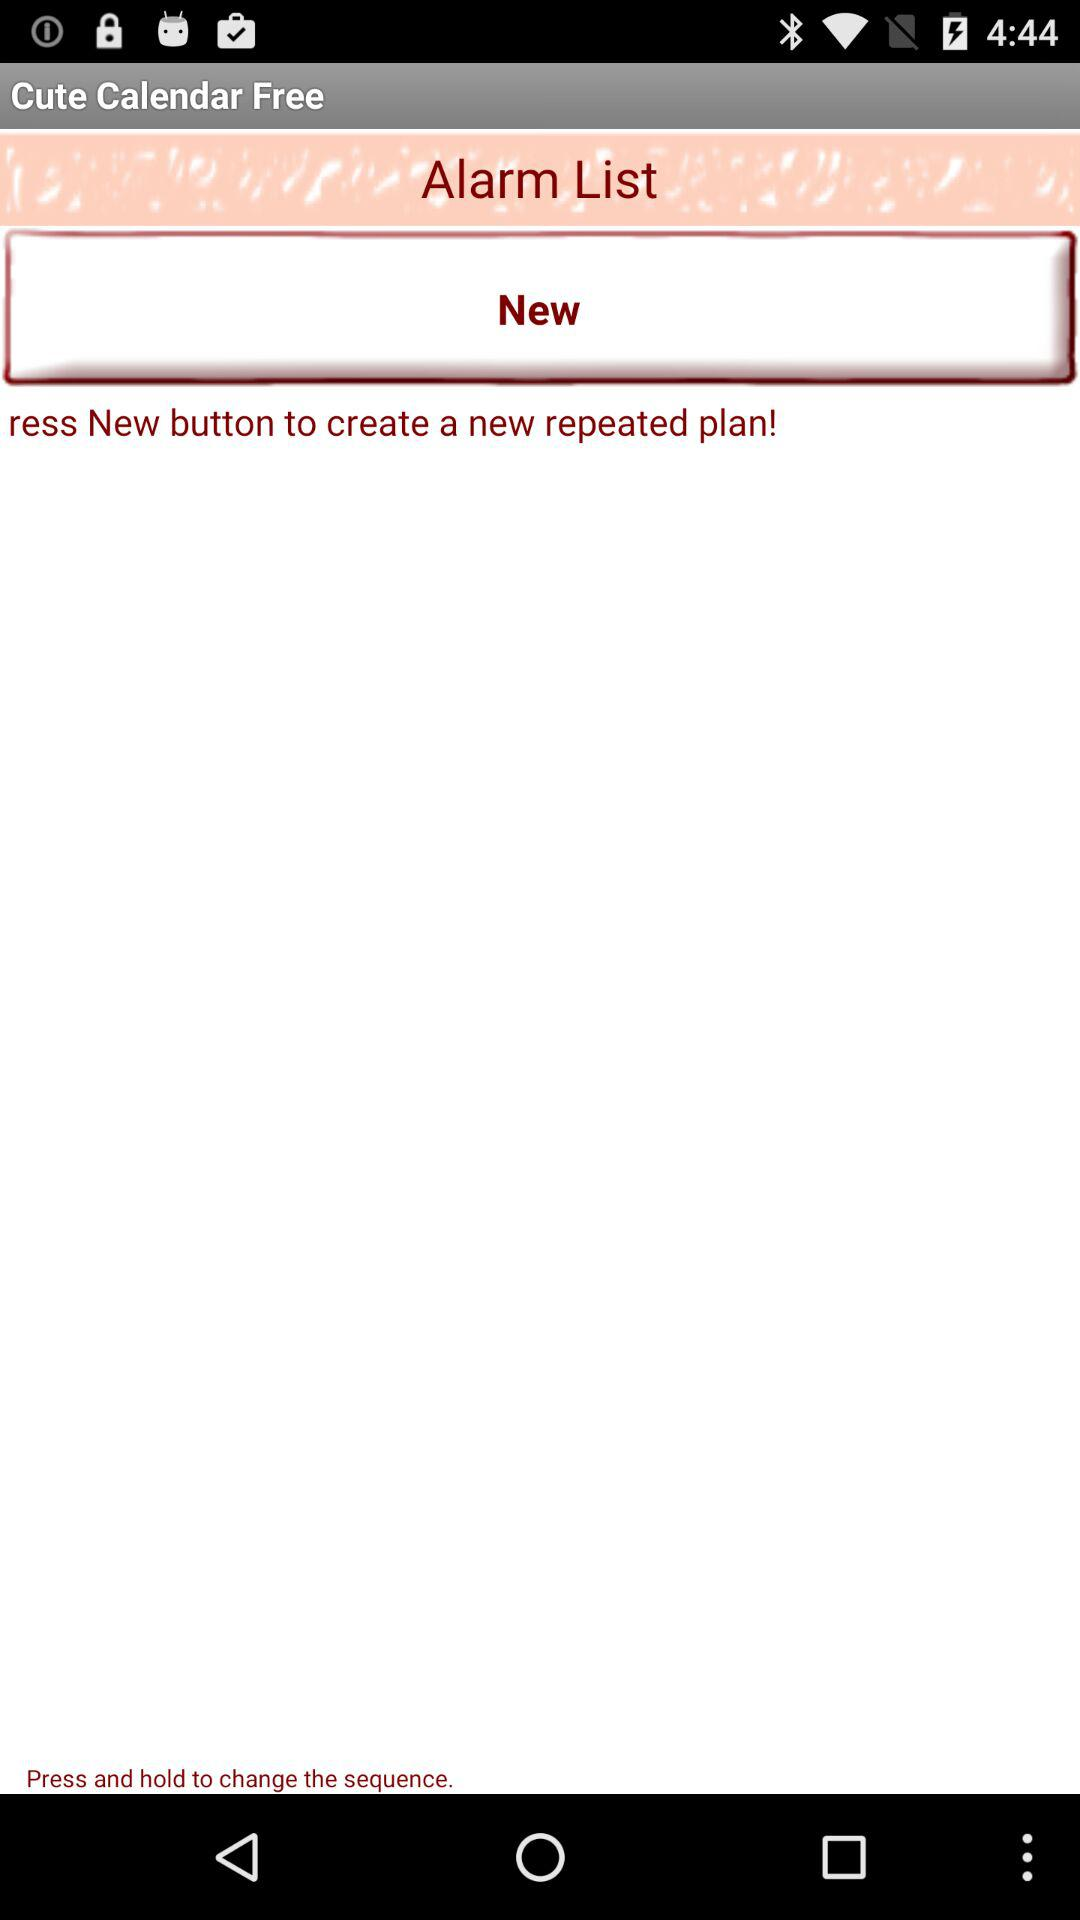Can you describe what features might be accessible through this application, based on what's visible? From the visible interface, the 'Cute Calendar Free' app shows features such as an Alarm List, with functionalities likely including the setting of new alarms and possibly scheduling repetitive tasks or reminders. The user interface suggests easy-to-navigate options and simple design for managing time-based activities. What do you think the 'Press and hold to change the sequence' implies about functionality? The instruction 'Press and hold to change the sequence' implies that the app allows users to modify the order of alarms or tasks in the list. This functionality can be particularly useful for prioritizing more urgent reminders or reorganizing them as plans change. 